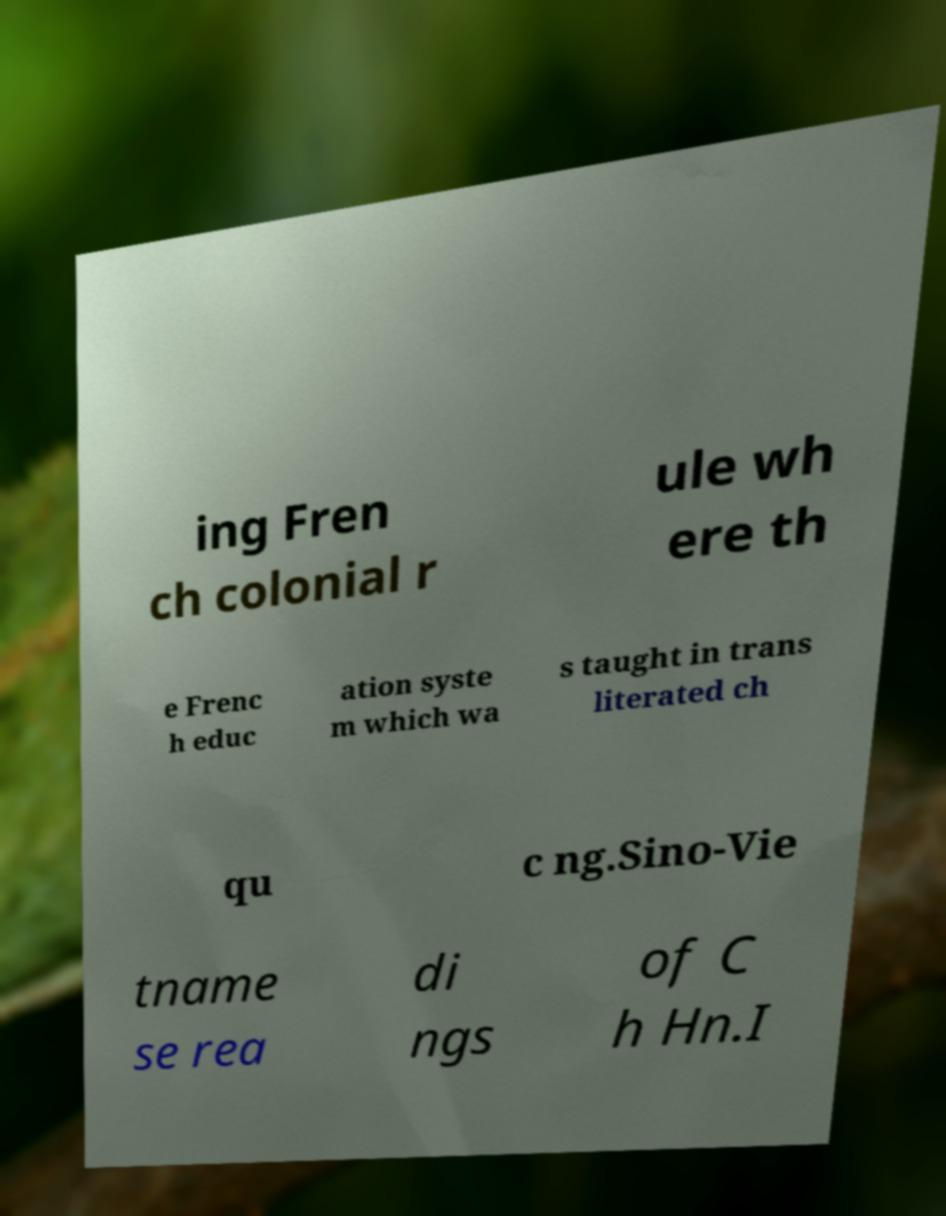I need the written content from this picture converted into text. Can you do that? ing Fren ch colonial r ule wh ere th e Frenc h educ ation syste m which wa s taught in trans literated ch qu c ng.Sino-Vie tname se rea di ngs of C h Hn.I 